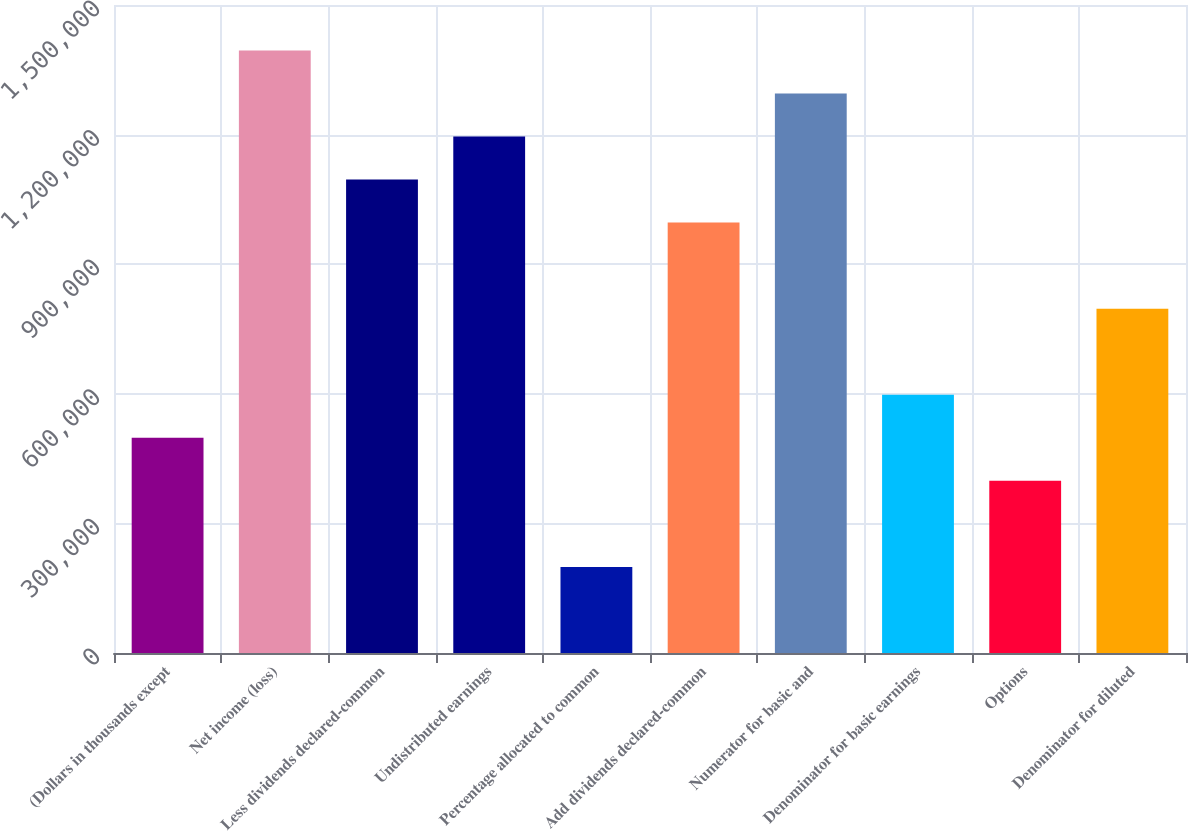Convert chart to OTSL. <chart><loc_0><loc_0><loc_500><loc_500><bar_chart><fcel>(Dollars in thousands except<fcel>Net income (loss)<fcel>Less dividends declared-common<fcel>Undistributed earnings<fcel>Percentage allocated to common<fcel>Add dividends declared-common<fcel>Numerator for basic and<fcel>Denominator for basic earnings<fcel>Options<fcel>Denominator for diluted<nl><fcel>498184<fcel>1.39487e+06<fcel>1.09598e+06<fcel>1.19561e+06<fcel>199288<fcel>996344<fcel>1.29524e+06<fcel>597816<fcel>398552<fcel>797080<nl></chart> 